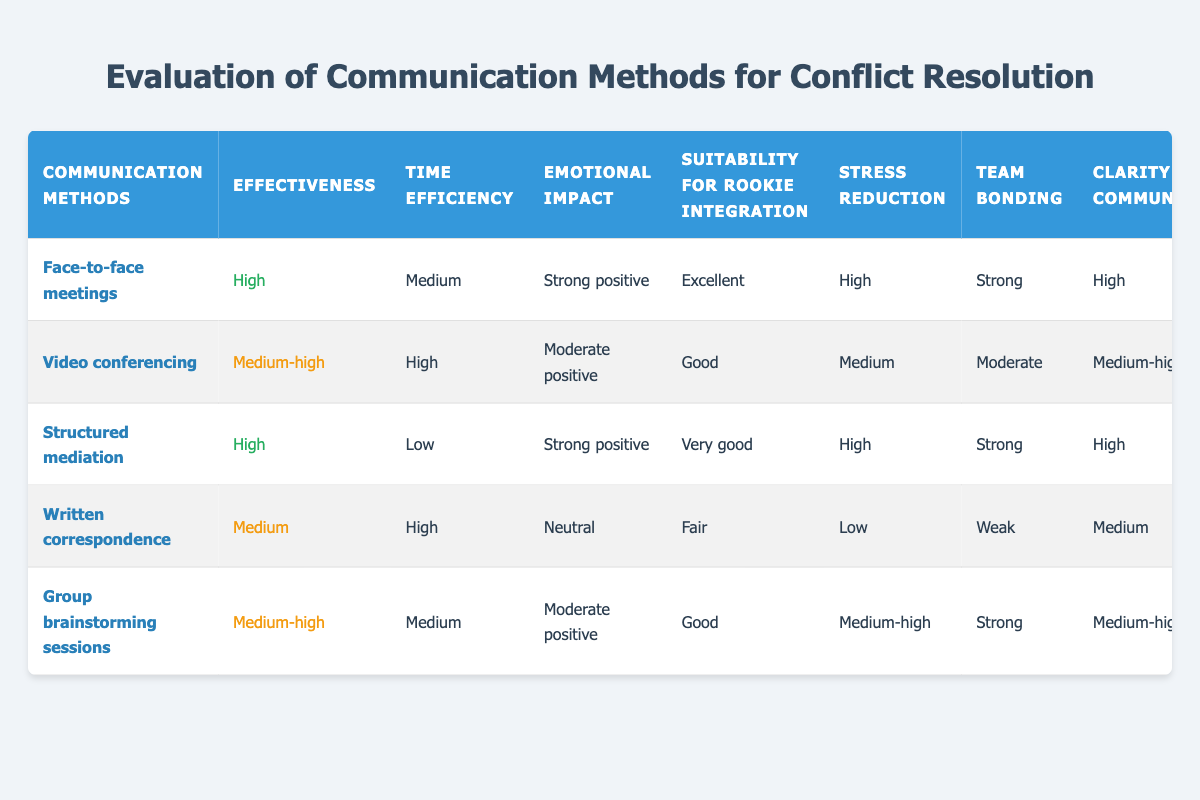What is the effectiveness level of face-to-face meetings? The effectiveness level for face-to-face meetings is explicitly stated in the table under the "Effectiveness" column. It shows "High" for this method.
Answer: High Which communication methods have a strong positive emotional impact? The table lists the emotional impact for each method. Face-to-face meetings and structured mediation both have a "Strong positive" emotional impact.
Answer: Face-to-face meetings, Structured mediation How many communication methods have low follow-up requirements? By checking the "Follow-up Required" column, we count the entries that say "Low," which are under face-to-face meetings, structured mediation, and written correspondence. This gives a total of 3 methods.
Answer: 3 What is the difference in time efficiency between video conferencing and structured mediation? The "Time Efficiency" columns show "High" for video conferencing and "Low" for structured mediation. Therefore, the difference in efficiency is that video conferencing is more efficient (high) compared to structured mediation (low).
Answer: Video conferencing is more efficient Are group brainstorming sessions suitable for rookie integration? The table indicates that group brainstorming sessions have a rating of "Good" for suitability for rookie integration, which answers the question in the affirmative.
Answer: Yes Which methods have medium-high effectiveness? Looking at the "Effectiveness" column, we see that video conferencing and group brainstorming sessions both fall under "Medium-high."
Answer: Video conferencing, Group brainstorming sessions What is the average stress reduction level for all communication methods? To find the average stress reduction, we note the levels: High (3), Medium (2), Medium-high (1), and Low (1). Transforming these into numerical values (High=3, Medium-high=2, Medium=1, Low=0), we get (3 + 2 + 3 + 0 + 2) / 5 = 10 / 5 = 2. The average corresponds to a "Medium" level as it is above 1 but below 3.
Answer: Medium Is there a communication method with a weak team bonding score? The table specifies that written correspondence has a "Weak" rating for team bonding. Hence, the answer is yes – this method does exhibit weak bonding.
Answer: Yes 